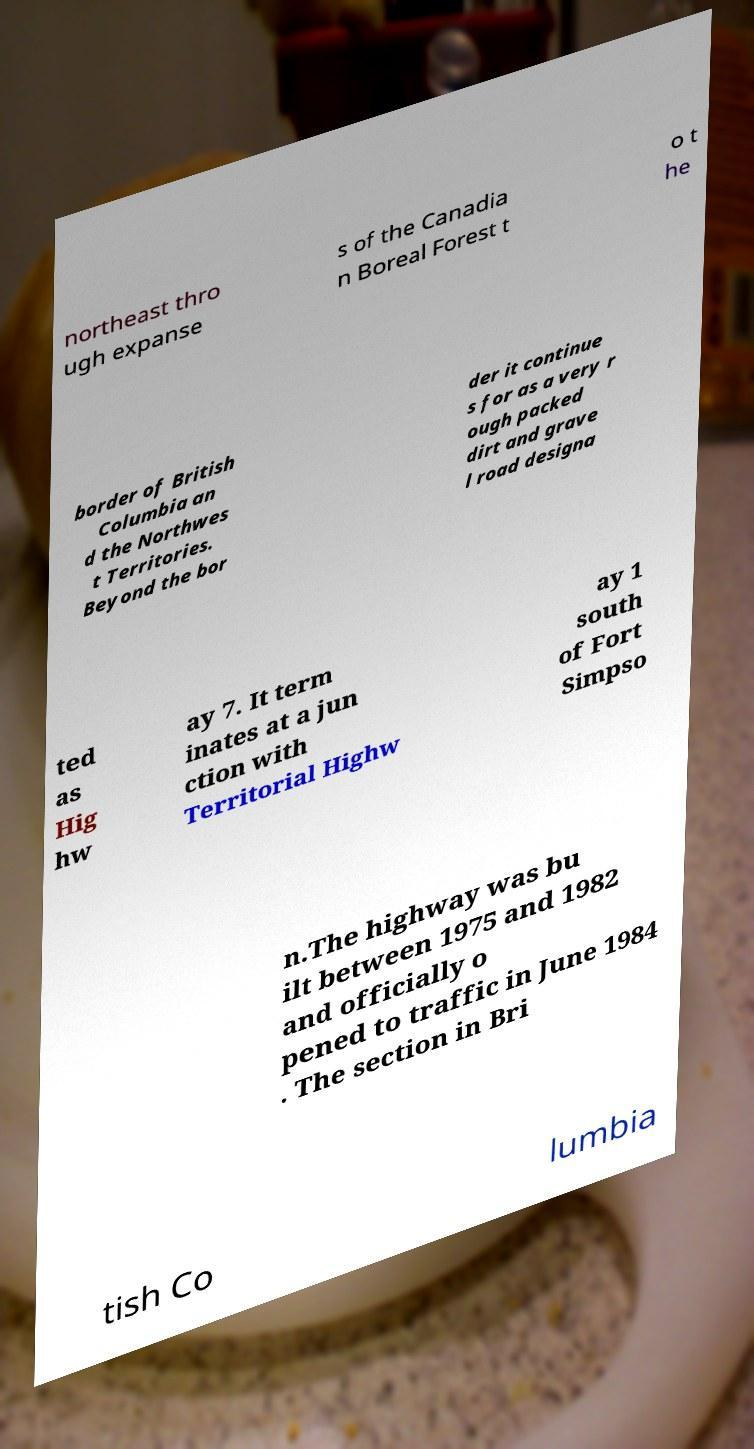Can you accurately transcribe the text from the provided image for me? northeast thro ugh expanse s of the Canadia n Boreal Forest t o t he border of British Columbia an d the Northwes t Territories. Beyond the bor der it continue s for as a very r ough packed dirt and grave l road designa ted as Hig hw ay 7. It term inates at a jun ction with Territorial Highw ay 1 south of Fort Simpso n.The highway was bu ilt between 1975 and 1982 and officially o pened to traffic in June 1984 . The section in Bri tish Co lumbia 